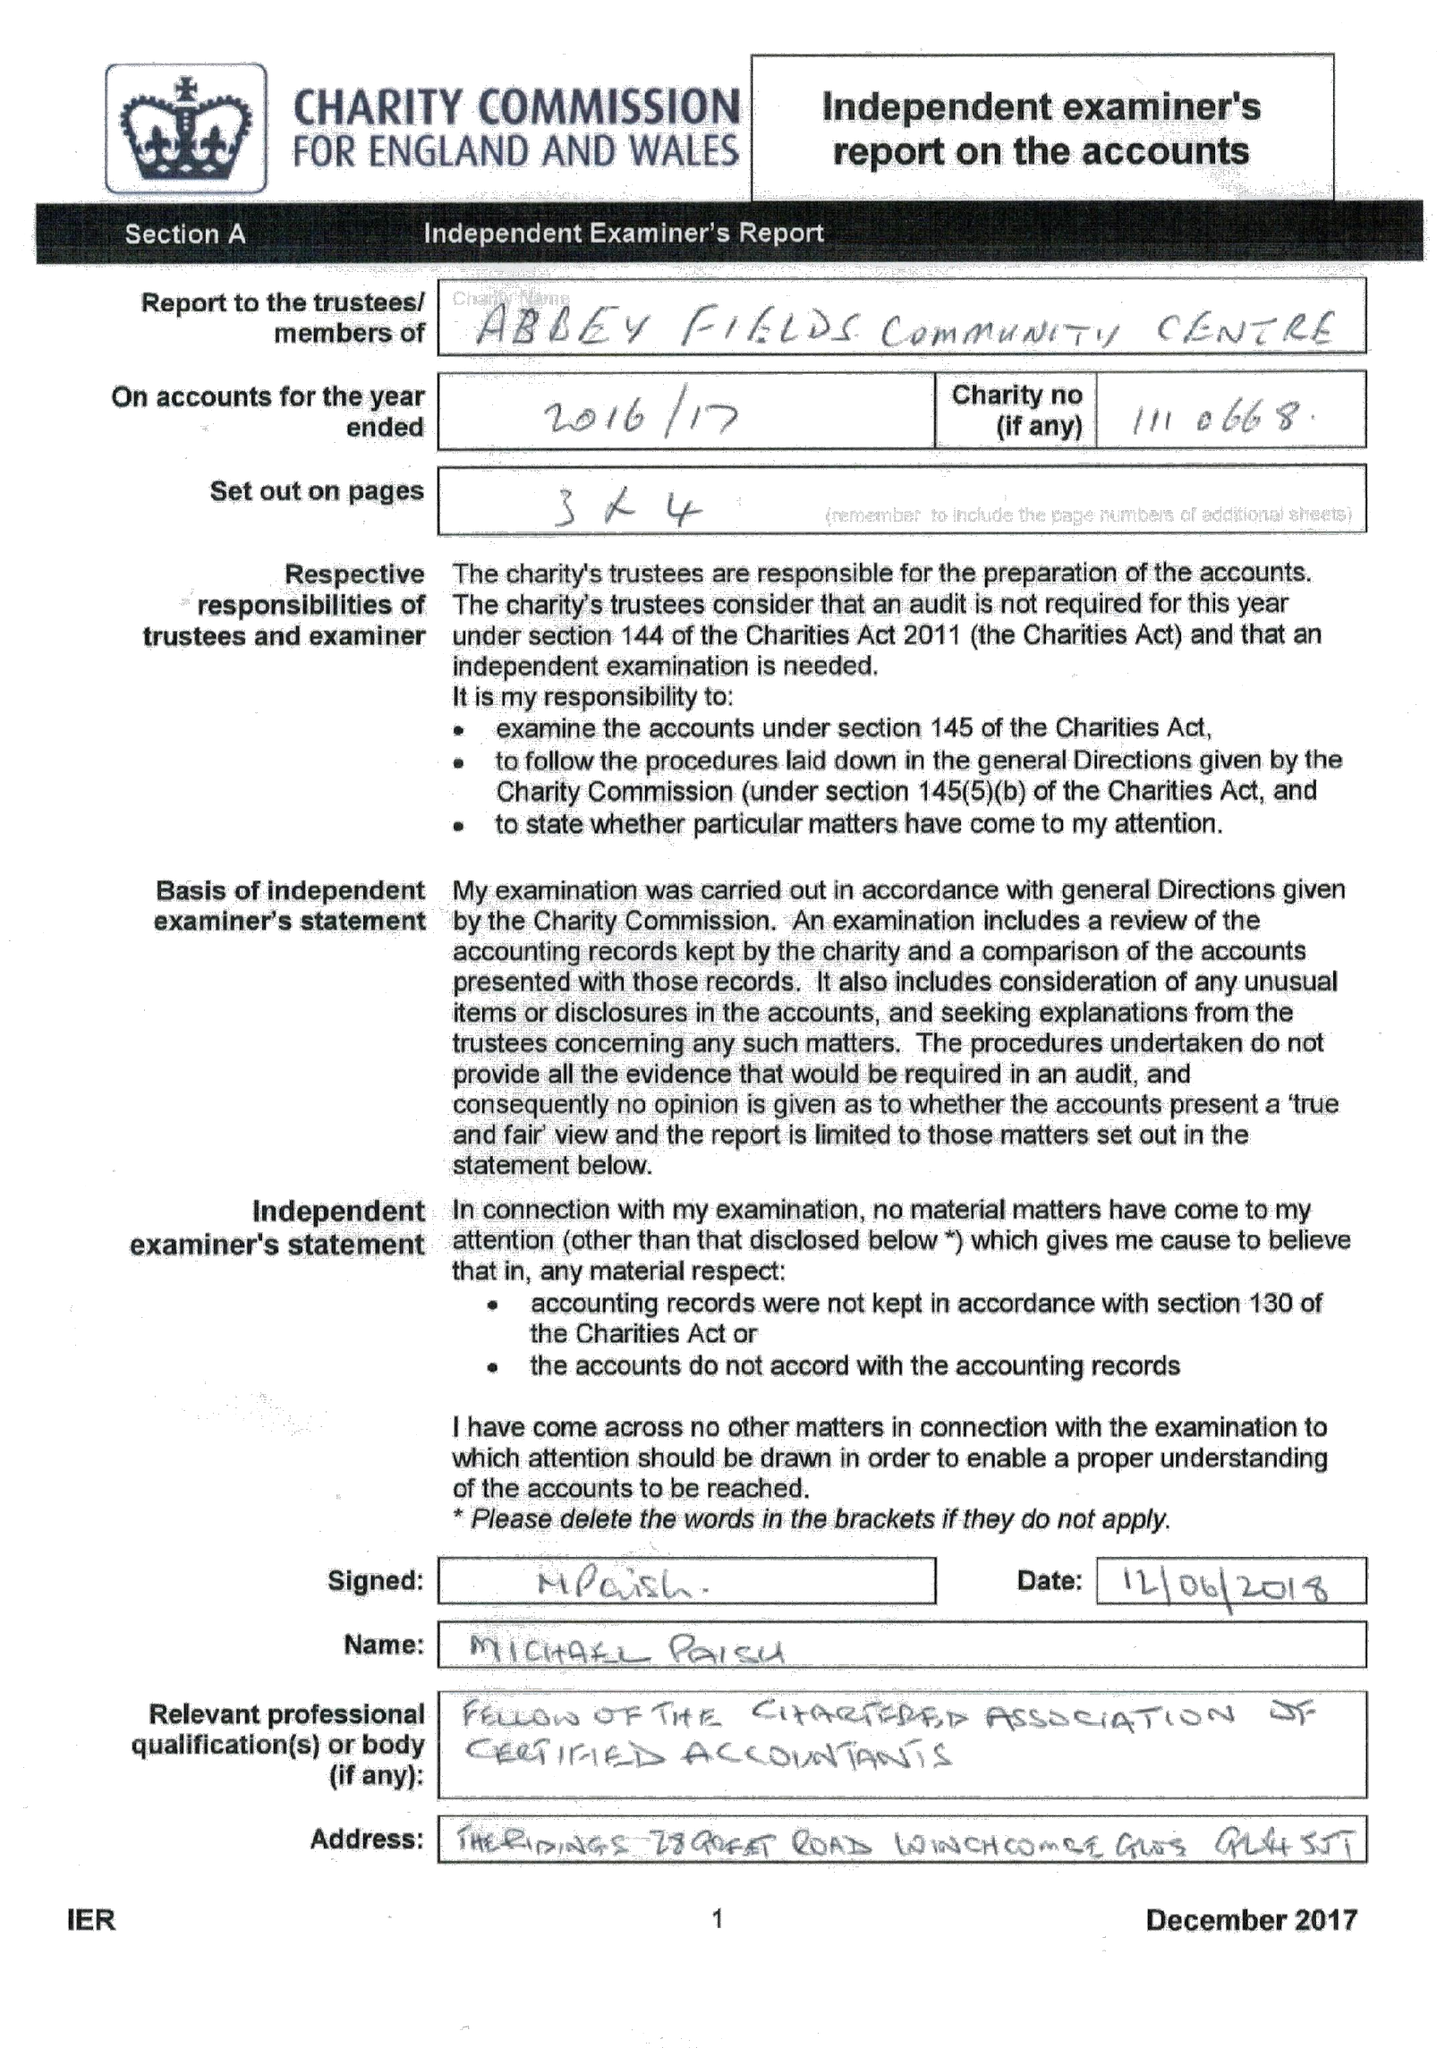What is the value for the report_date?
Answer the question using a single word or phrase. 2017-03-31 